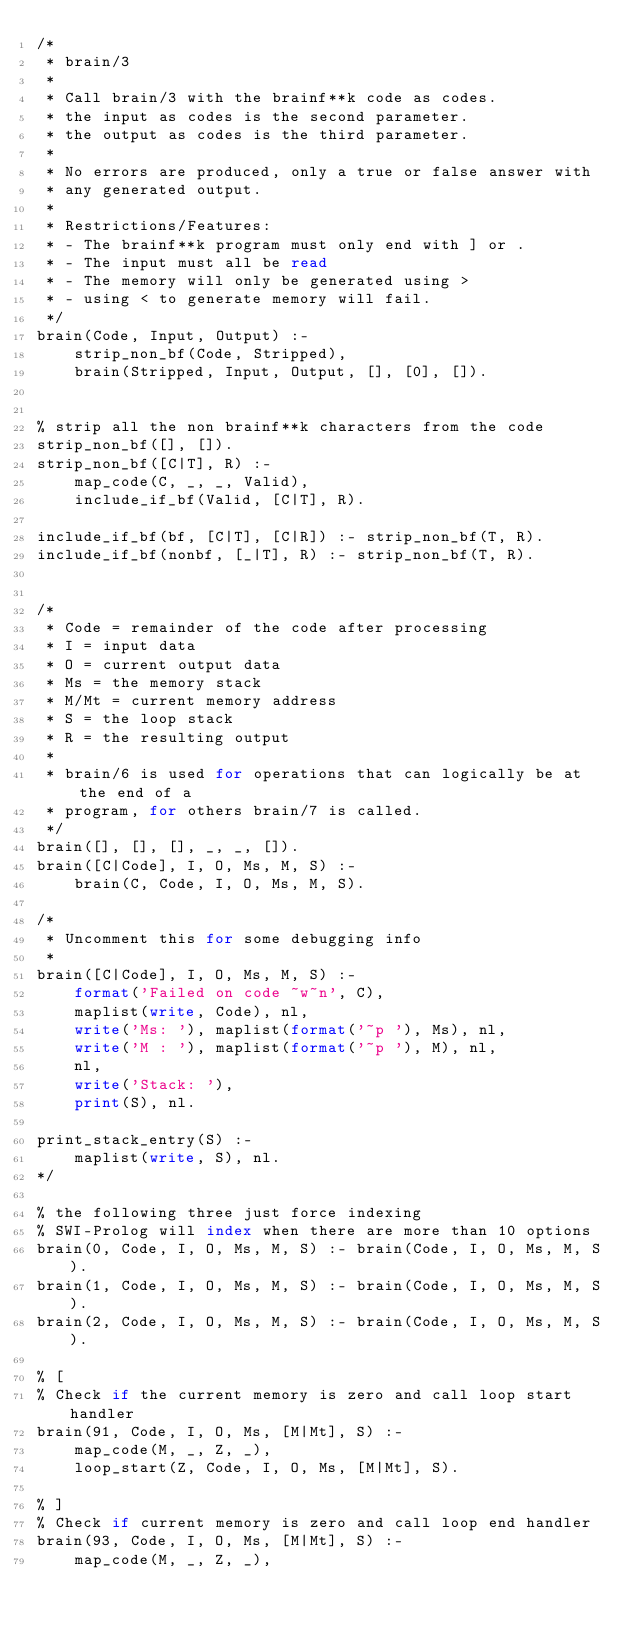<code> <loc_0><loc_0><loc_500><loc_500><_Perl_>/*
 * brain/3
 *
 * Call brain/3 with the brainf**k code as codes.
 * the input as codes is the second parameter.
 * the output as codes is the third parameter.
 *
 * No errors are produced, only a true or false answer with
 * any generated output.
 *
 * Restrictions/Features:
 * - The brainf**k program must only end with ] or .
 * - The input must all be read
 * - The memory will only be generated using >
 * - using < to generate memory will fail.
 */
brain(Code, Input, Output) :-
    strip_non_bf(Code, Stripped),
    brain(Stripped, Input, Output, [], [0], []).


% strip all the non brainf**k characters from the code
strip_non_bf([], []).
strip_non_bf([C|T], R) :-
    map_code(C, _, _, Valid),
    include_if_bf(Valid, [C|T], R).

include_if_bf(bf, [C|T], [C|R]) :- strip_non_bf(T, R).
include_if_bf(nonbf, [_|T], R) :- strip_non_bf(T, R).


/*
 * Code = remainder of the code after processing
 * I = input data
 * O = current output data
 * Ms = the memory stack
 * M/Mt = current memory address
 * S = the loop stack
 * R = the resulting output
 *
 * brain/6 is used for operations that can logically be at the end of a
 * program, for others brain/7 is called.
 */
brain([], [], [], _, _, []).
brain([C|Code], I, O, Ms, M, S) :-
    brain(C, Code, I, O, Ms, M, S).

/*
 * Uncomment this for some debugging info
 *
brain([C|Code], I, O, Ms, M, S) :-
    format('Failed on code ~w~n', C),
    maplist(write, Code), nl,
    write('Ms: '), maplist(format('~p '), Ms), nl,
    write('M : '), maplist(format('~p '), M), nl,
    nl,
    write('Stack: '),
    print(S), nl.

print_stack_entry(S) :-
    maplist(write, S), nl.
*/

% the following three just force indexing
% SWI-Prolog will index when there are more than 10 options
brain(0, Code, I, O, Ms, M, S) :- brain(Code, I, O, Ms, M, S).
brain(1, Code, I, O, Ms, M, S) :- brain(Code, I, O, Ms, M, S).
brain(2, Code, I, O, Ms, M, S) :- brain(Code, I, O, Ms, M, S).

% [
% Check if the current memory is zero and call loop start handler
brain(91, Code, I, O, Ms, [M|Mt], S) :-
    map_code(M, _, Z, _),
    loop_start(Z, Code, I, O, Ms, [M|Mt], S).

% ]
% Check if current memory is zero and call loop end handler
brain(93, Code, I, O, Ms, [M|Mt], S) :-
    map_code(M, _, Z, _),</code> 